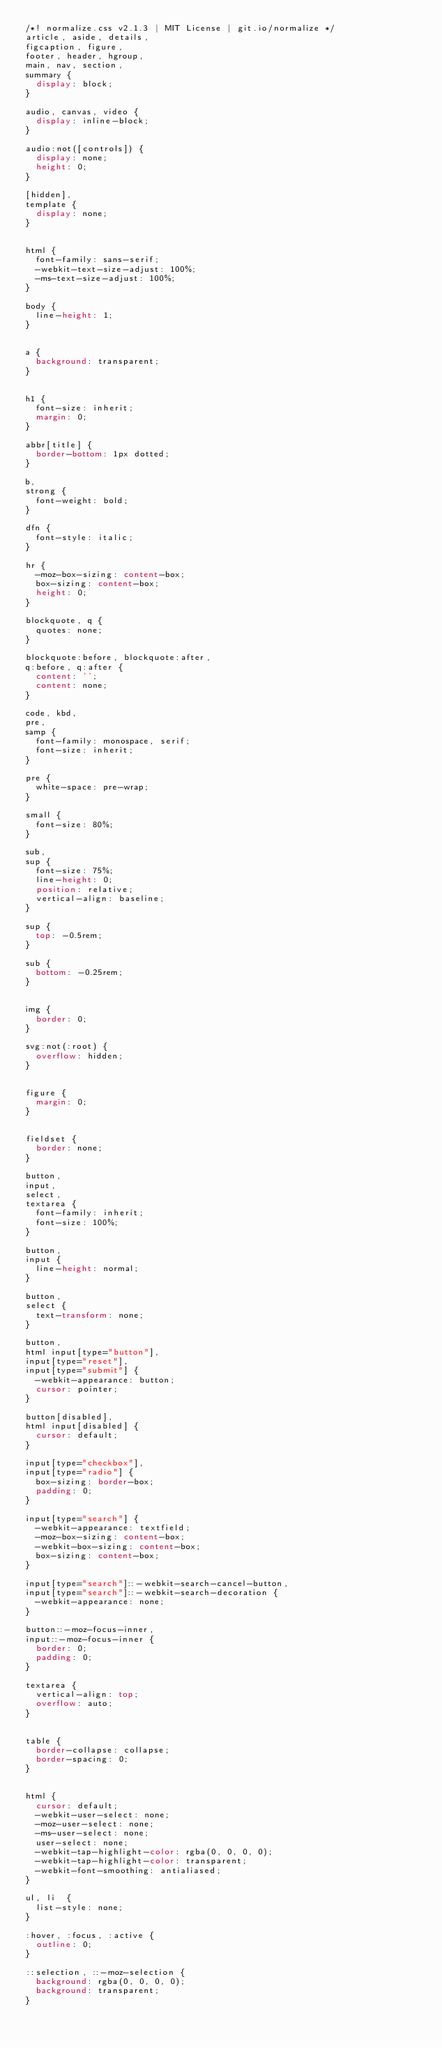<code> <loc_0><loc_0><loc_500><loc_500><_CSS_>/*! normalize.css v2.1.3 | MIT License | git.io/normalize */
article, aside, details,
figcaption, figure,
footer, header, hgroup,
main, nav, section,
summary {
	display: block;
}

audio, canvas, video {
	display: inline-block;
}

audio:not([controls]) {
	display: none;
	height: 0;
}

[hidden],
template {
	display: none;
}


html {
	font-family: sans-serif;
	-webkit-text-size-adjust: 100%;
	-ms-text-size-adjust: 100%;
}

body {
	line-height: 1;
}


a {
	background: transparent;
}


h1 {
	font-size: inherit;
	margin: 0;
}

abbr[title] {
	border-bottom: 1px dotted;
}

b,
strong {
	font-weight: bold;
}

dfn {
	font-style: italic;
}

hr {
	-moz-box-sizing: content-box;
	box-sizing: content-box;
	height: 0;
}

blockquote, q {
	quotes: none;
}

blockquote:before, blockquote:after,
q:before, q:after {
	content: '';
	content: none;
}

code, kbd,
pre,
samp {
	font-family: monospace, serif;
	font-size: inherit;
}

pre {
	white-space: pre-wrap;
}

small {
	font-size: 80%;
}

sub,
sup {
	font-size: 75%;
	line-height: 0;
	position: relative;
	vertical-align: baseline;
}

sup {
	top: -0.5rem;
}

sub {
	bottom: -0.25rem;
}


img {
	border: 0;
}

svg:not(:root) {
	overflow: hidden;
}


figure {
	margin: 0;
}


fieldset {
	border: none;
}

button,
input,
select,
textarea {
	font-family: inherit;
	font-size: 100%;
}

button,
input {
	line-height: normal;
}

button,
select {
	text-transform: none;
}

button,
html input[type="button"],
input[type="reset"],
input[type="submit"] {
	-webkit-appearance: button;
	cursor: pointer;
}

button[disabled],
html input[disabled] {
	cursor: default;
}

input[type="checkbox"],
input[type="radio"] {
	box-sizing: border-box;
	padding: 0;
}

input[type="search"] {
	-webkit-appearance: textfield;
	-moz-box-sizing: content-box;
	-webkit-box-sizing: content-box;
	box-sizing: content-box;
}

input[type="search"]::-webkit-search-cancel-button,
input[type="search"]::-webkit-search-decoration {
	-webkit-appearance: none;
}

button::-moz-focus-inner,
input::-moz-focus-inner {
	border: 0;
	padding: 0;
}

textarea {
	vertical-align: top;
	overflow: auto;
}


table {
	border-collapse: collapse;
	border-spacing: 0;
}


html {
	cursor: default;
	-webkit-user-select: none;
	-moz-user-select: none;
	-ms-user-select: none;
	user-select: none;
	-webkit-tap-highlight-color: rgba(0, 0, 0, 0);
	-webkit-tap-highlight-color: transparent;
	-webkit-font-smoothing: antialiased;
}

ul, li	{
	list-style: none;
}

:hover, :focus, :active {
	outline: 0;
}

::selection, ::-moz-selection {
	background: rgba(0, 0, 0, 0);
	background: transparent;
}</code> 